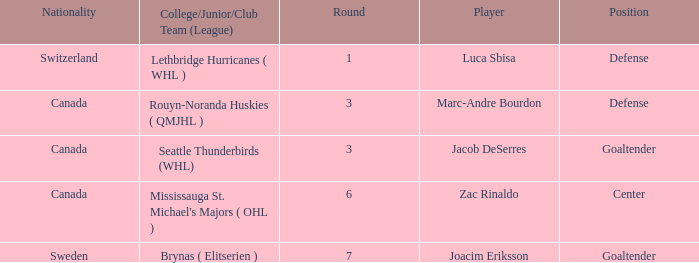What position did Luca Sbisa play for the Philadelphia Flyers? Defense. 